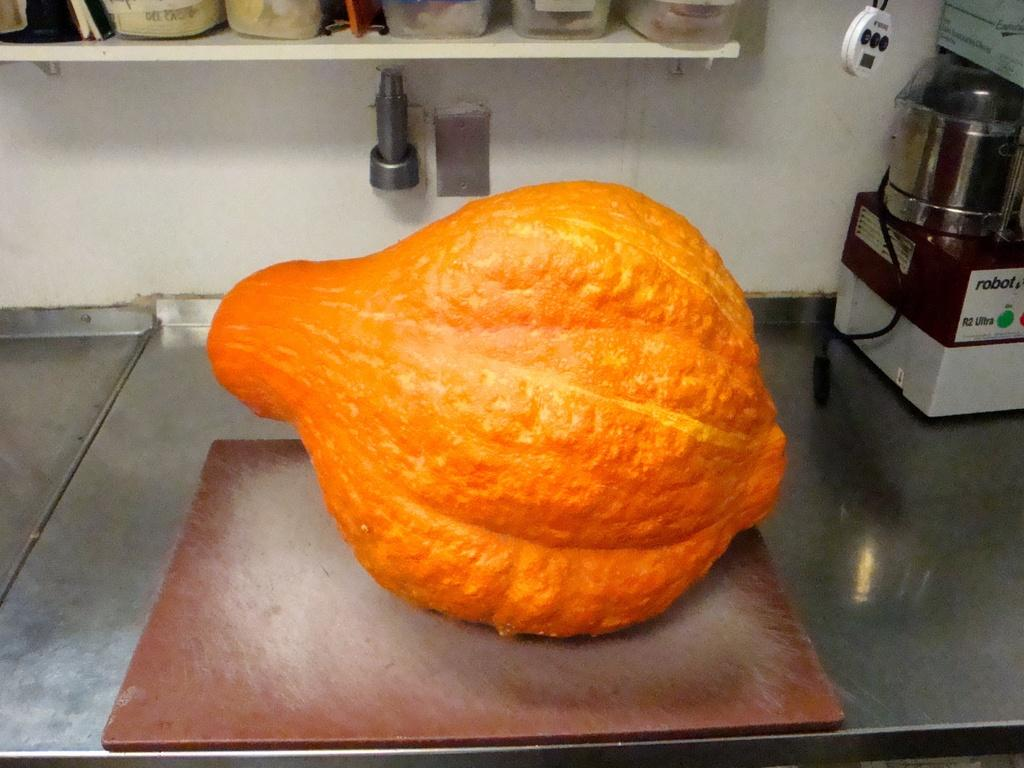<image>
Present a compact description of the photo's key features. A huge orange gourd on a cutting board next  to a robot brand kitchen appliance.] 